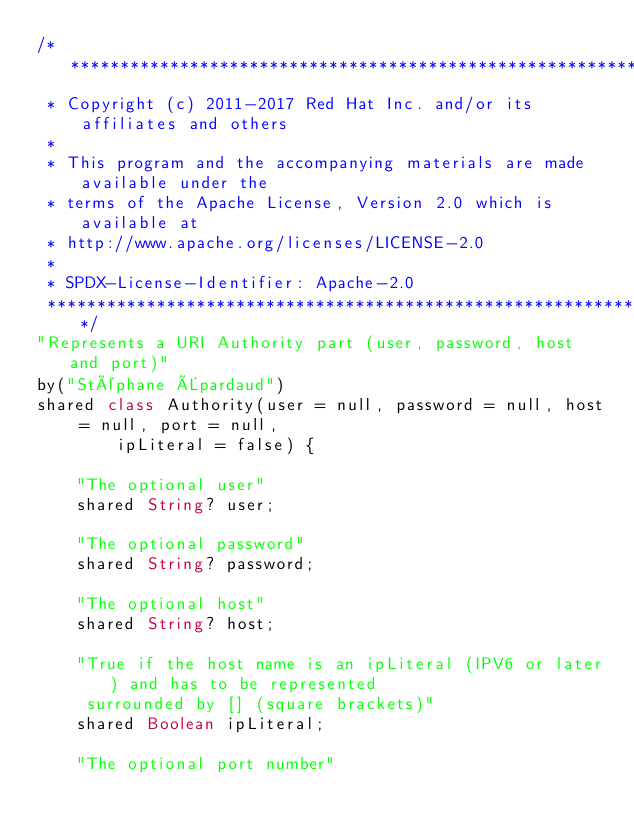Convert code to text. <code><loc_0><loc_0><loc_500><loc_500><_Ceylon_>/********************************************************************************
 * Copyright (c) 2011-2017 Red Hat Inc. and/or its affiliates and others
 *
 * This program and the accompanying materials are made available under the 
 * terms of the Apache License, Version 2.0 which is available at
 * http://www.apache.org/licenses/LICENSE-2.0
 *
 * SPDX-License-Identifier: Apache-2.0 
 ********************************************************************************/
"Represents a URI Authority part (user, password, host and port)"
by("Stéphane Épardaud")
shared class Authority(user = null, password = null, host = null, port = null,
        ipLiteral = false) {

    "The optional user"
    shared String? user;

    "The optional password"
    shared String? password;

    "The optional host"
    shared String? host;

    "True if the host name is an ipLiteral (IPV6 or later) and has to be represented
     surrounded by [] (square brackets)"
    shared Boolean ipLiteral;

    "The optional port number"</code> 